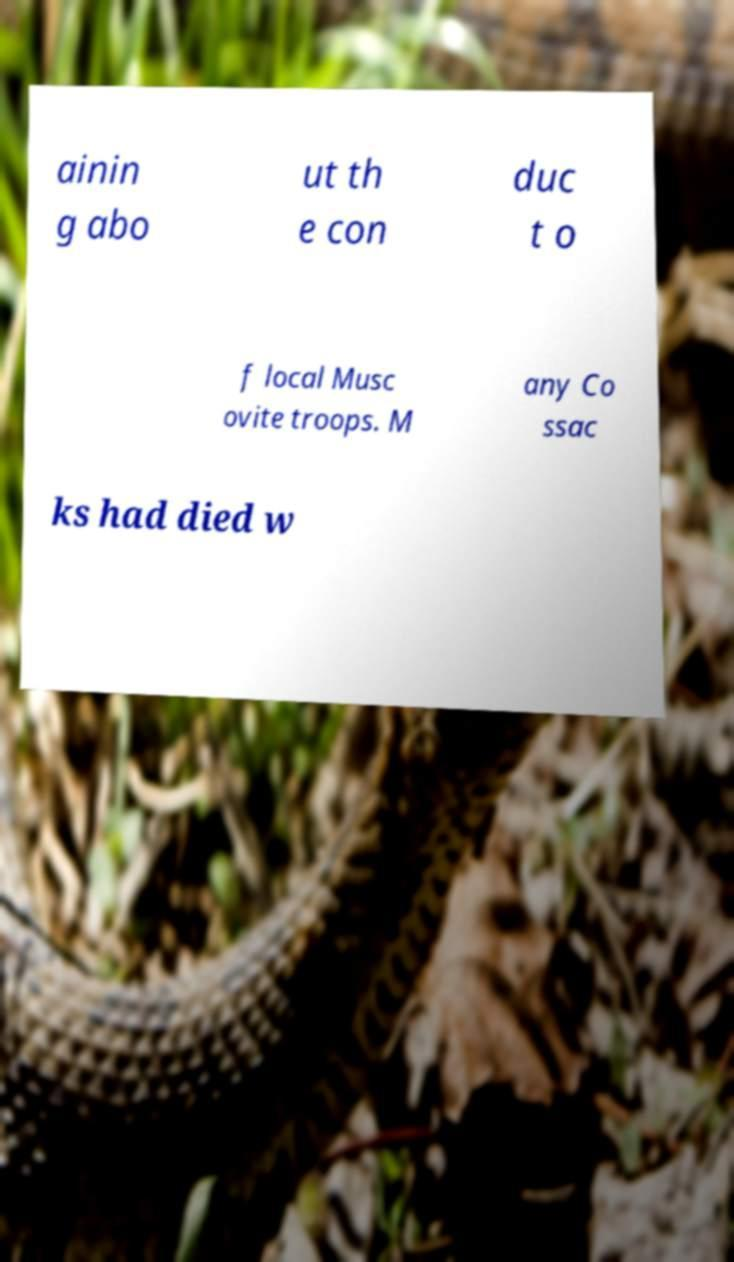For documentation purposes, I need the text within this image transcribed. Could you provide that? ainin g abo ut th e con duc t o f local Musc ovite troops. M any Co ssac ks had died w 